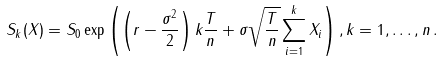<formula> <loc_0><loc_0><loc_500><loc_500>S _ { k } ( X ) = S _ { 0 } \exp \left ( \left ( r - \frac { \sigma ^ { 2 } } { 2 } \right ) k \frac { T } { n } + \sigma \sqrt { \frac { T } { n } } \sum _ { i = 1 } ^ { k } X _ { i } \right ) , k = 1 , \dots , n \, .</formula> 